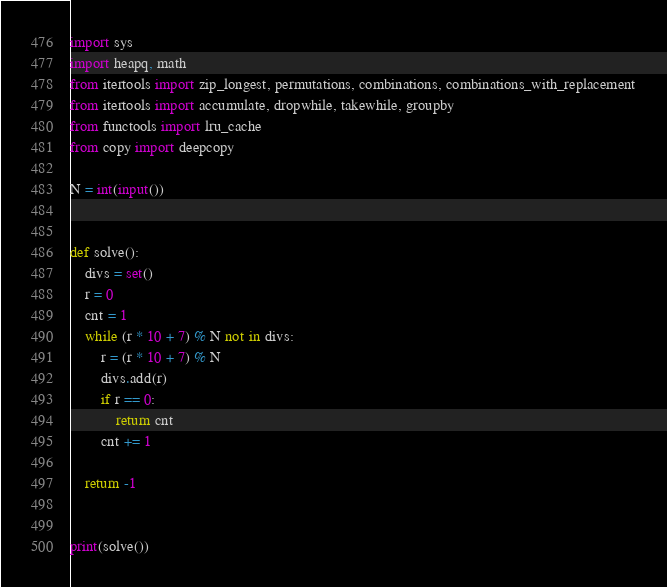Convert code to text. <code><loc_0><loc_0><loc_500><loc_500><_Python_>import sys
import heapq, math
from itertools import zip_longest, permutations, combinations, combinations_with_replacement
from itertools import accumulate, dropwhile, takewhile, groupby
from functools import lru_cache
from copy import deepcopy

N = int(input())


def solve():
    divs = set()
    r = 0
    cnt = 1
    while (r * 10 + 7) % N not in divs:
        r = (r * 10 + 7) % N
        divs.add(r)
        if r == 0:
            return cnt
        cnt += 1

    return -1


print(solve())</code> 